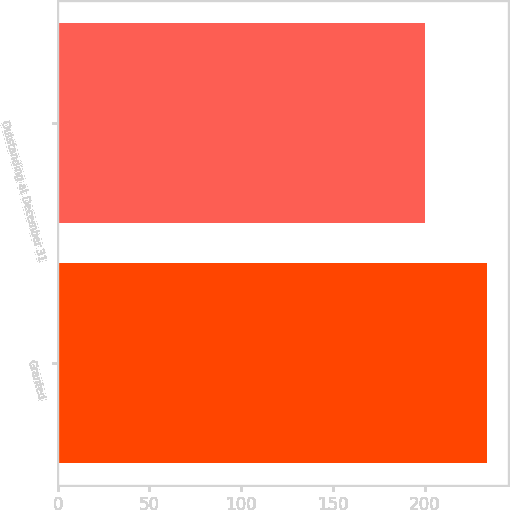Convert chart to OTSL. <chart><loc_0><loc_0><loc_500><loc_500><bar_chart><fcel>Granted<fcel>Outstanding at December 31<nl><fcel>234.03<fcel>200.02<nl></chart> 